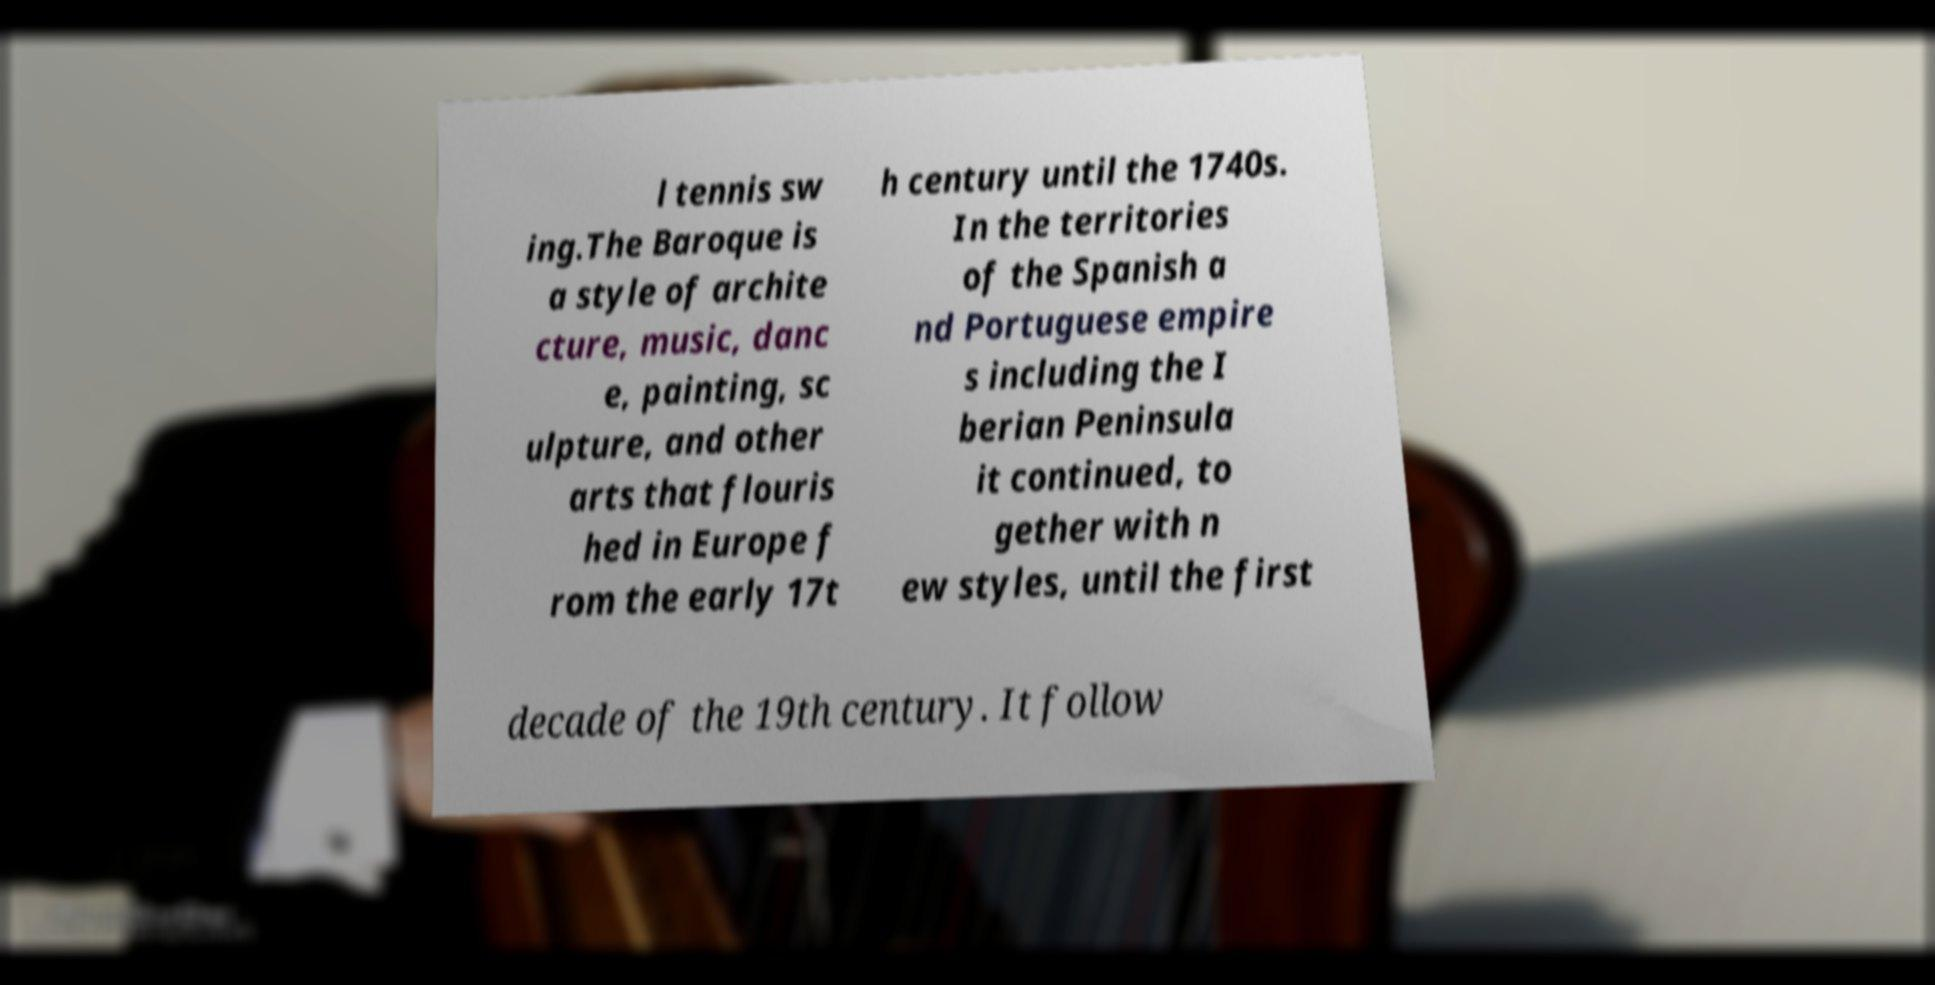For documentation purposes, I need the text within this image transcribed. Could you provide that? l tennis sw ing.The Baroque is a style of archite cture, music, danc e, painting, sc ulpture, and other arts that flouris hed in Europe f rom the early 17t h century until the 1740s. In the territories of the Spanish a nd Portuguese empire s including the I berian Peninsula it continued, to gether with n ew styles, until the first decade of the 19th century. It follow 